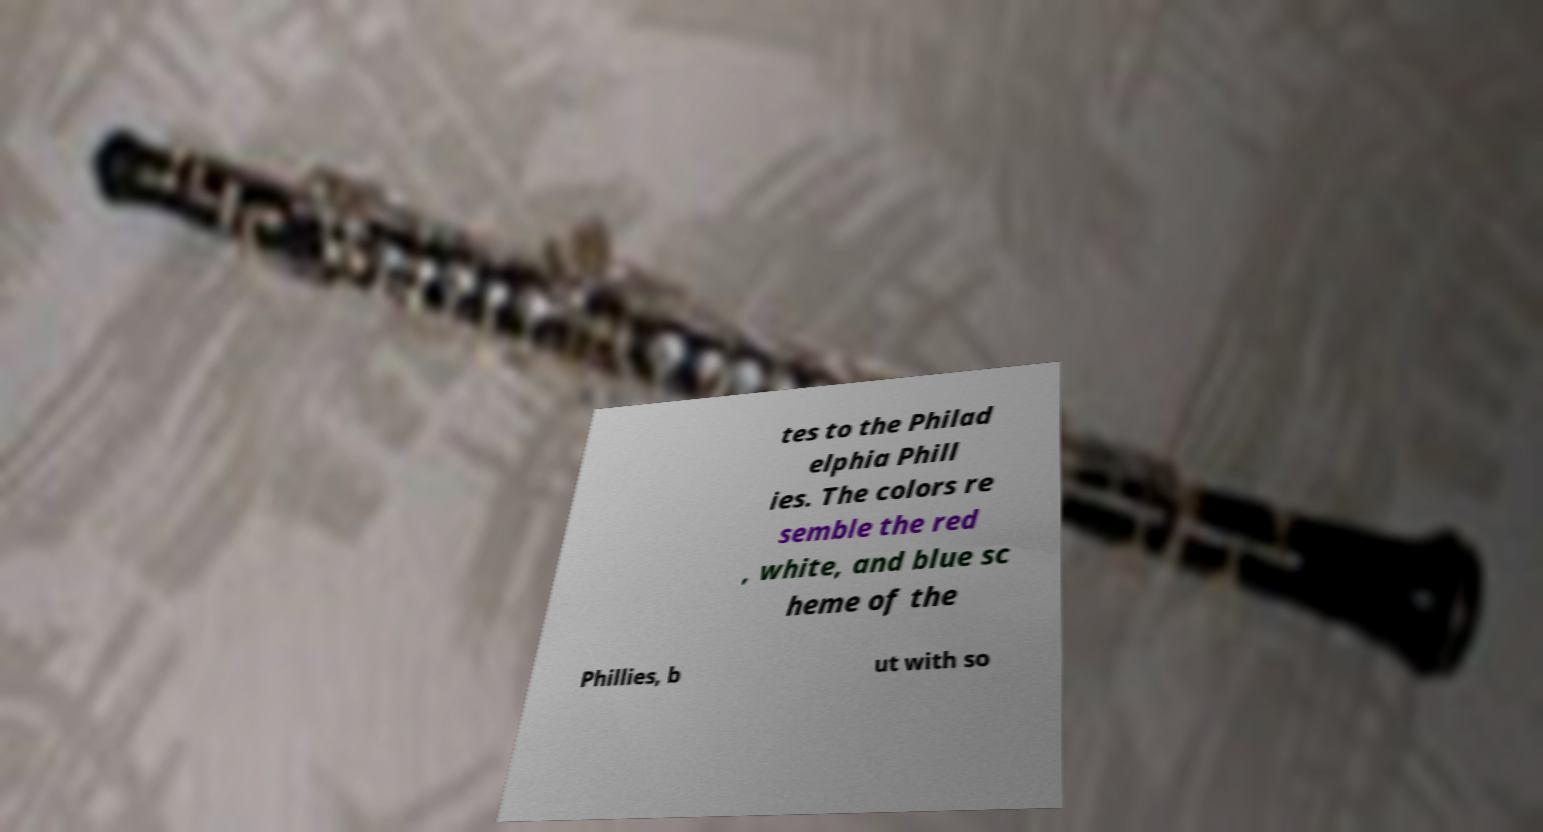What messages or text are displayed in this image? I need them in a readable, typed format. tes to the Philad elphia Phill ies. The colors re semble the red , white, and blue sc heme of the Phillies, b ut with so 